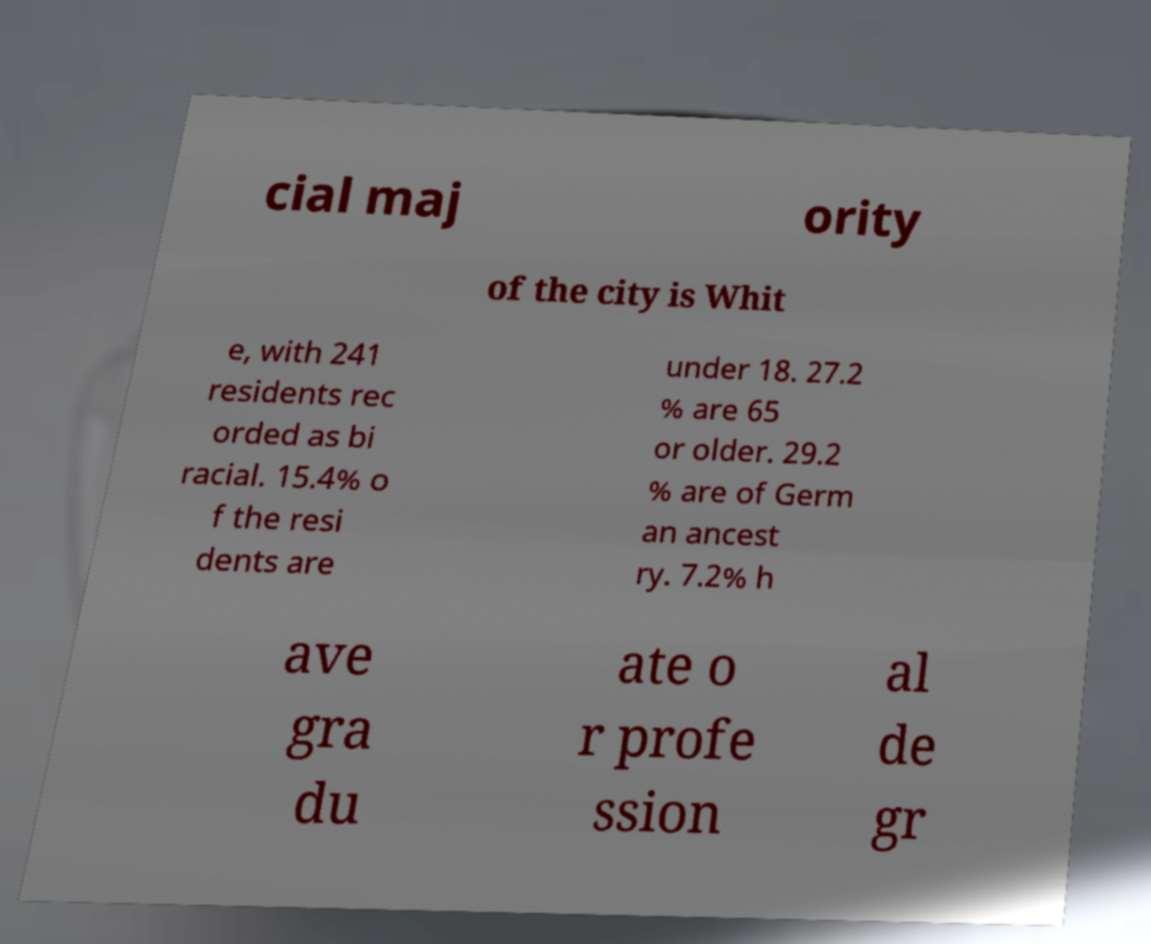Could you extract and type out the text from this image? cial maj ority of the city is Whit e, with 241 residents rec orded as bi racial. 15.4% o f the resi dents are under 18. 27.2 % are 65 or older. 29.2 % are of Germ an ancest ry. 7.2% h ave gra du ate o r profe ssion al de gr 